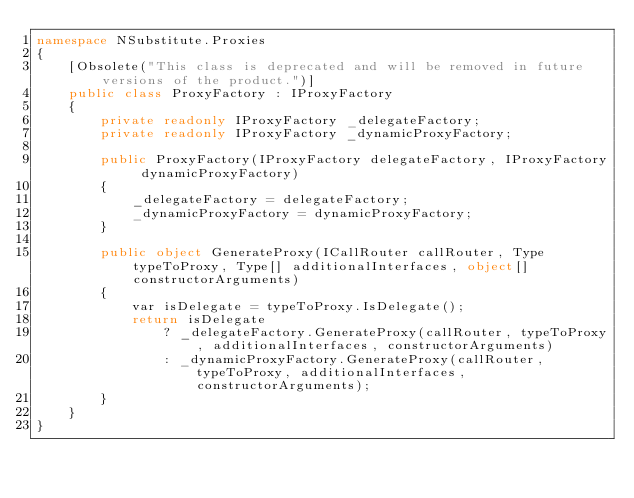<code> <loc_0><loc_0><loc_500><loc_500><_C#_>namespace NSubstitute.Proxies
{
    [Obsolete("This class is deprecated and will be removed in future versions of the product.")]
    public class ProxyFactory : IProxyFactory
    {
        private readonly IProxyFactory _delegateFactory;
        private readonly IProxyFactory _dynamicProxyFactory;

        public ProxyFactory(IProxyFactory delegateFactory, IProxyFactory dynamicProxyFactory)
        {
            _delegateFactory = delegateFactory;
            _dynamicProxyFactory = dynamicProxyFactory;
        }

        public object GenerateProxy(ICallRouter callRouter, Type typeToProxy, Type[] additionalInterfaces, object[] constructorArguments)
        {
            var isDelegate = typeToProxy.IsDelegate();
            return isDelegate 
                ? _delegateFactory.GenerateProxy(callRouter, typeToProxy, additionalInterfaces, constructorArguments)
                : _dynamicProxyFactory.GenerateProxy(callRouter, typeToProxy, additionalInterfaces, constructorArguments);
        }
    }
}</code> 